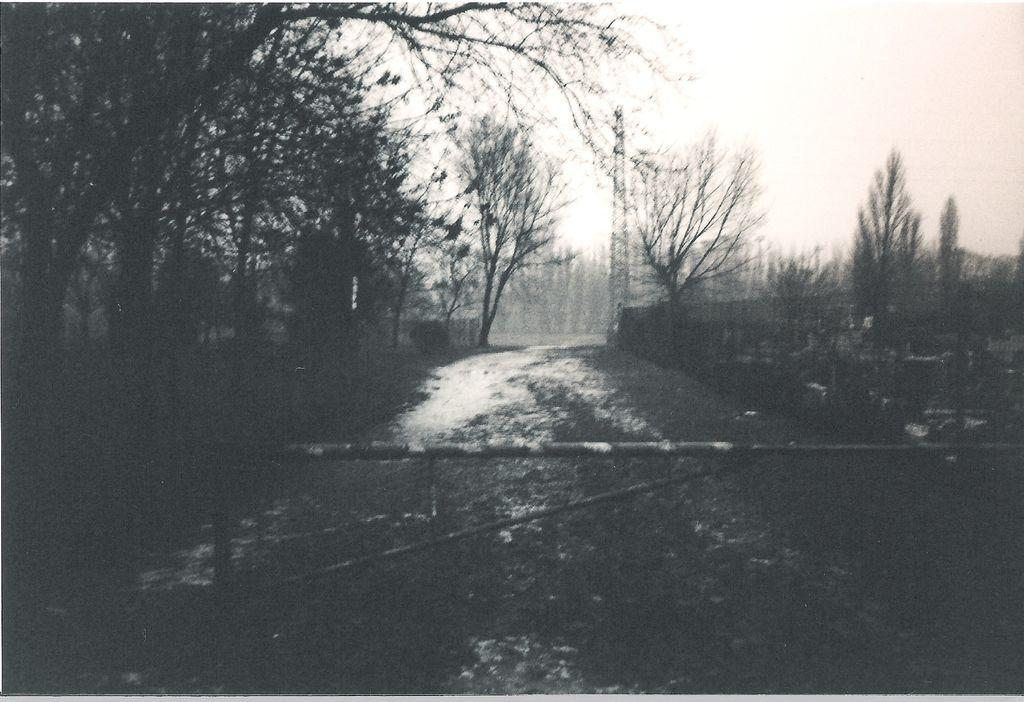What is the main feature of the landscape in the image? There is a road in the image. What type of vegetation can be seen in the image? There are trees in the image. What type of barrier is present in the image? There is fencing in the image. What type of structure can be seen in the image? There is a tower in the image. What is visible in the background of the image? The sky is visible in the background of the image. What type of transport can be seen rhythmically moving along the road in the image? There is no transport visible in the image, and therefore no such rhythmic movement can be observed. 